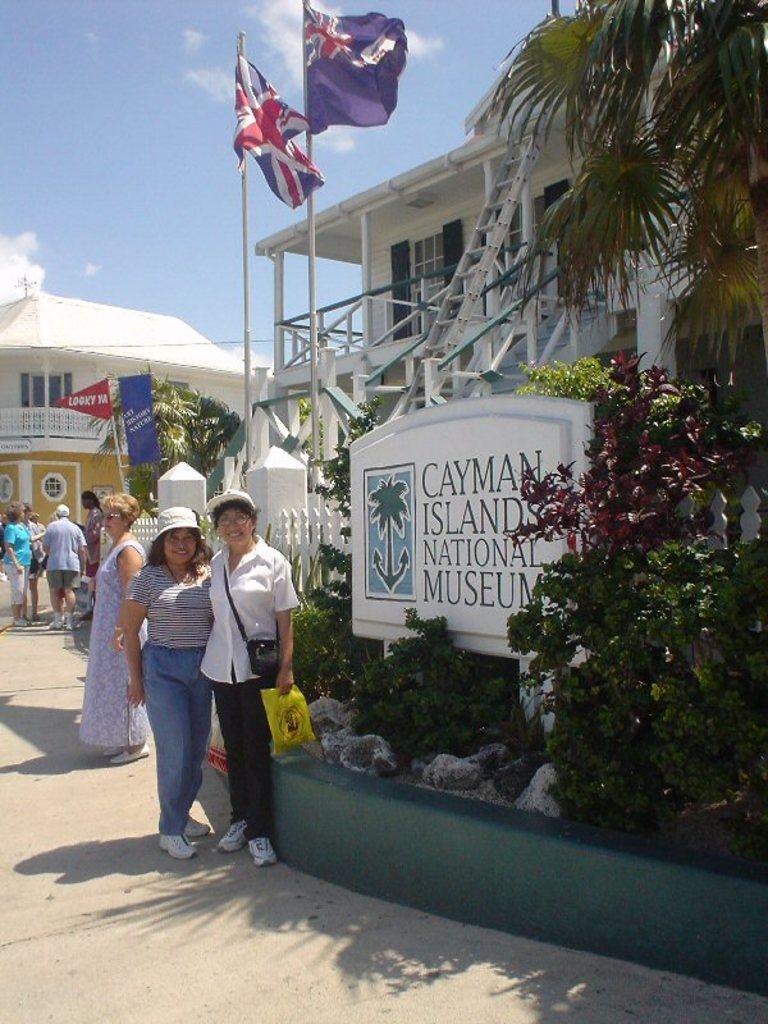Can you describe this image briefly? In this image, we can see some people standing and there are some plants, there are some buildings, at the top there is a blue sky. 